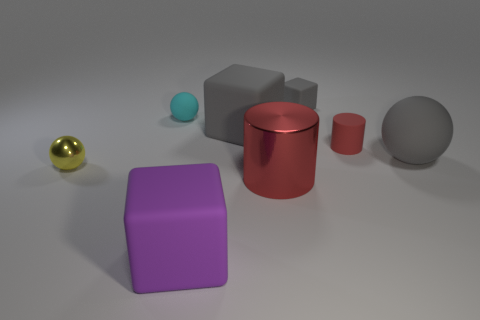Subtract all rubber spheres. How many spheres are left? 1 Add 1 tiny green cylinders. How many objects exist? 9 Subtract all cylinders. How many objects are left? 6 Subtract all small purple things. Subtract all red matte objects. How many objects are left? 7 Add 7 large gray matte balls. How many large gray matte balls are left? 8 Add 6 green cylinders. How many green cylinders exist? 6 Subtract 0 brown cylinders. How many objects are left? 8 